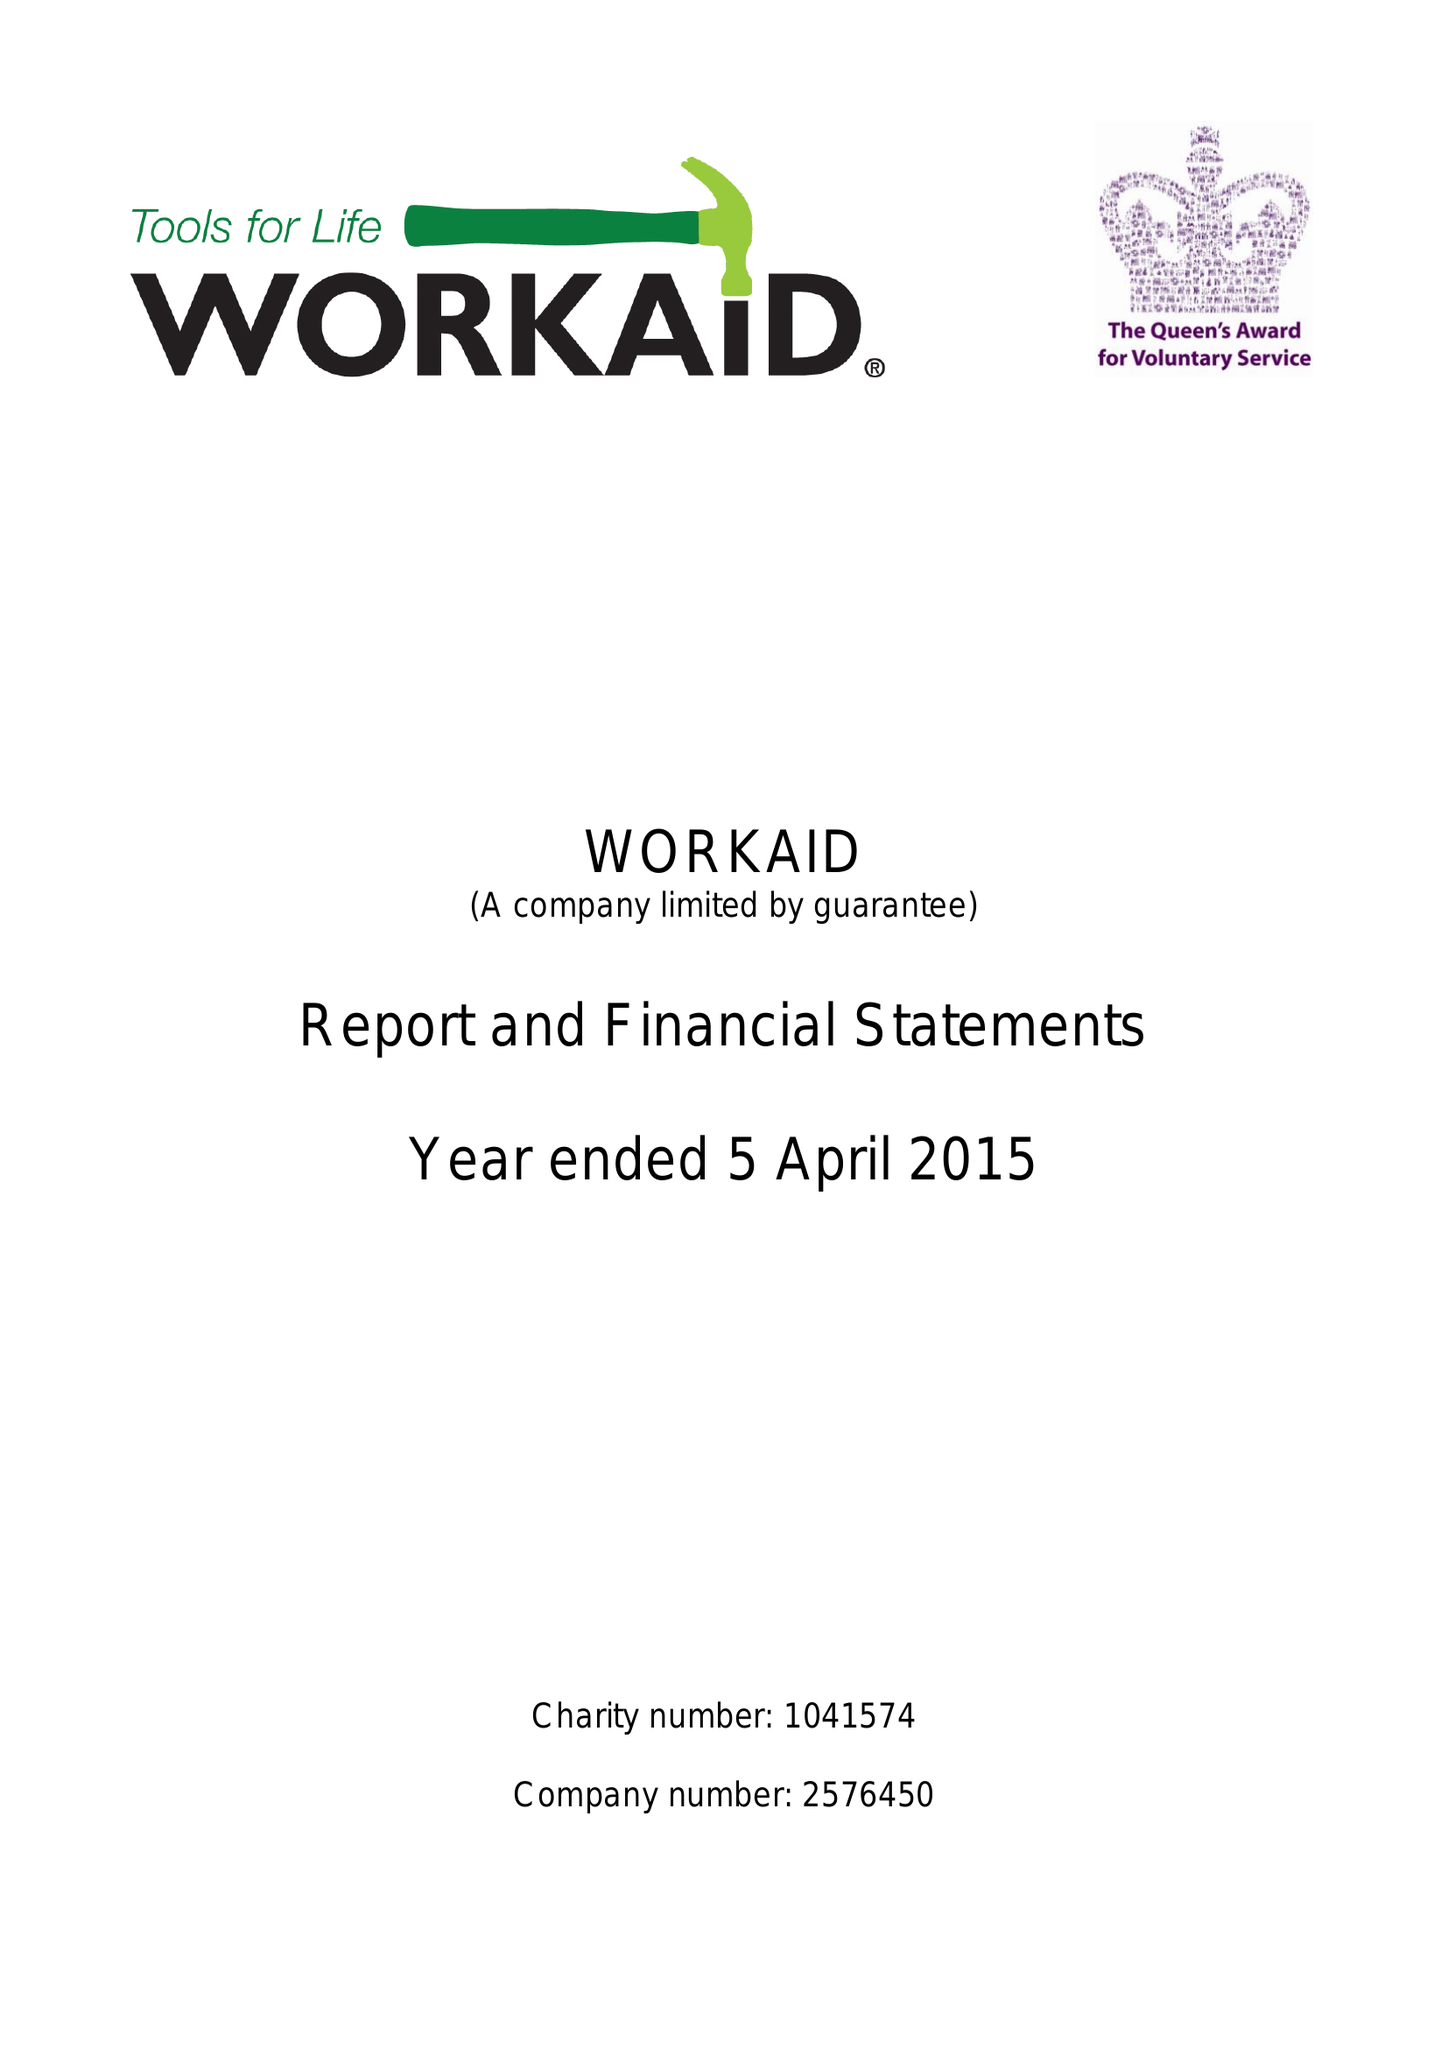What is the value for the charity_name?
Answer the question using a single word or phrase. Workaid 